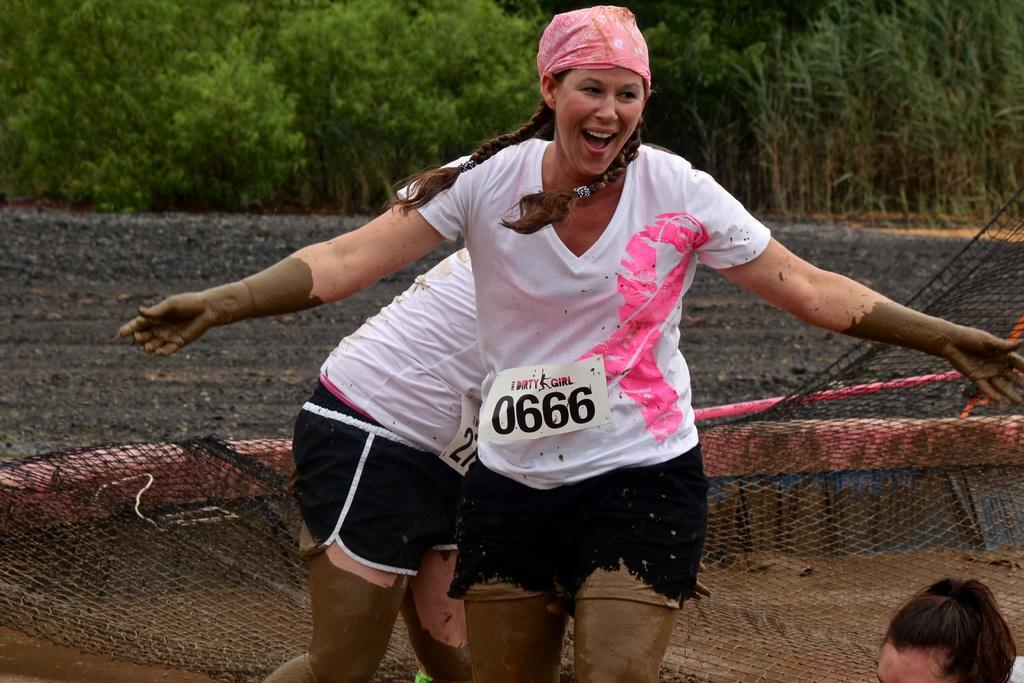<image>
Relay a brief, clear account of the picture shown. A woman is going through a muddy mass for The Dirty Girl marathon. 